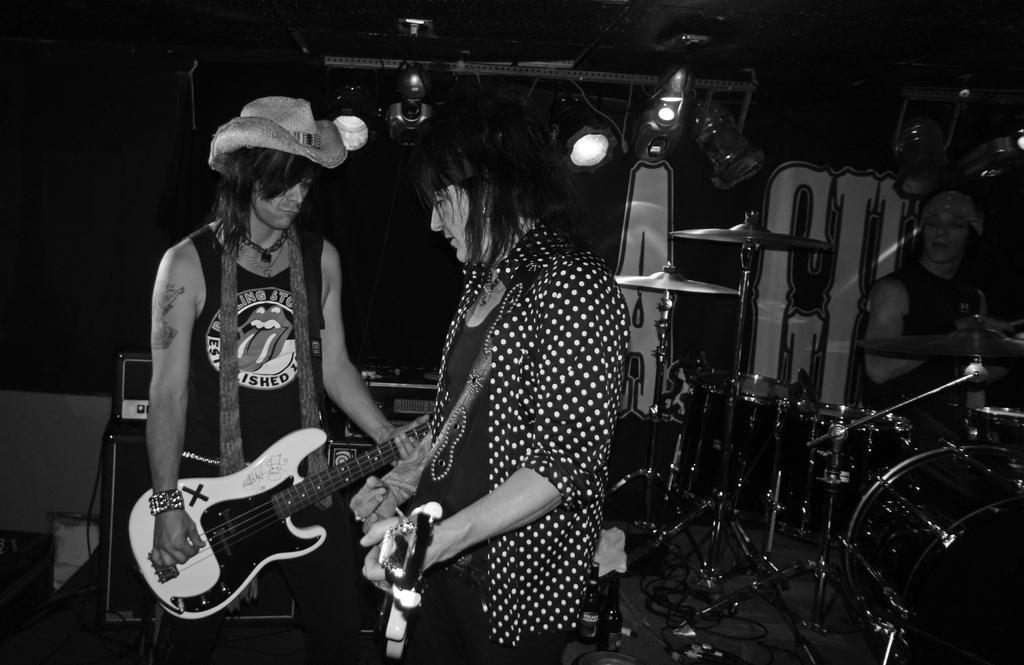Describe this image in one or two sentences. A black and white picture. These are musical instruments. This 2 persons are holding a guitar. This person wore hat. On top there are focusing lights. 